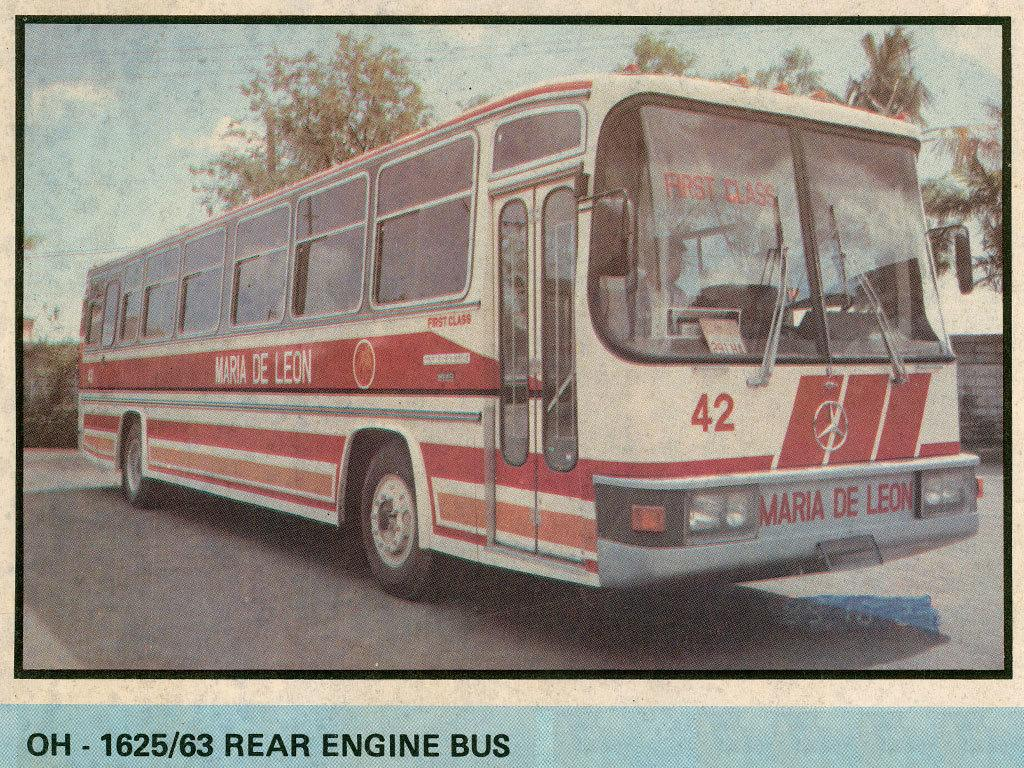What is the main subject of the image? There is a bus in the image. What color is the bus? The bus is red in color. What can be seen in the background of the image? There are trees visible in the image. Is there a sweater hanging on the trees in the image? No, there is no sweater present in the image. Can you see any mist in the image? No, there is no mist visible in the image. 